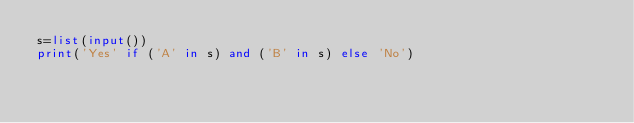Convert code to text. <code><loc_0><loc_0><loc_500><loc_500><_Python_>s=list(input())
print('Yes' if ('A' in s) and ('B' in s) else 'No')</code> 